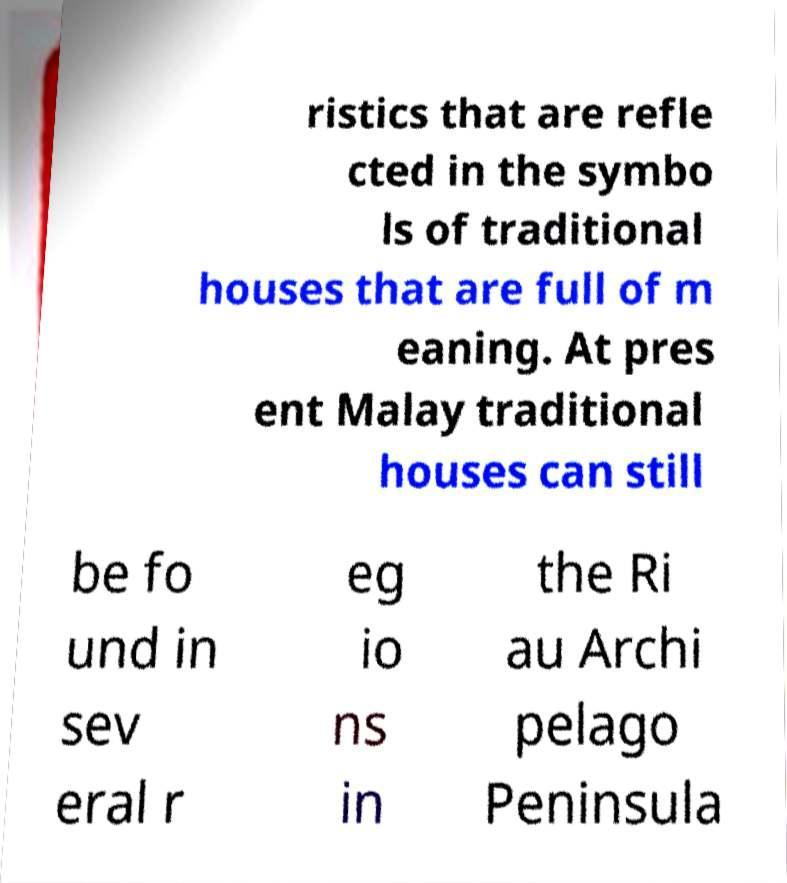Please read and relay the text visible in this image. What does it say? ristics that are refle cted in the symbo ls of traditional houses that are full of m eaning. At pres ent Malay traditional houses can still be fo und in sev eral r eg io ns in the Ri au Archi pelago Peninsula 